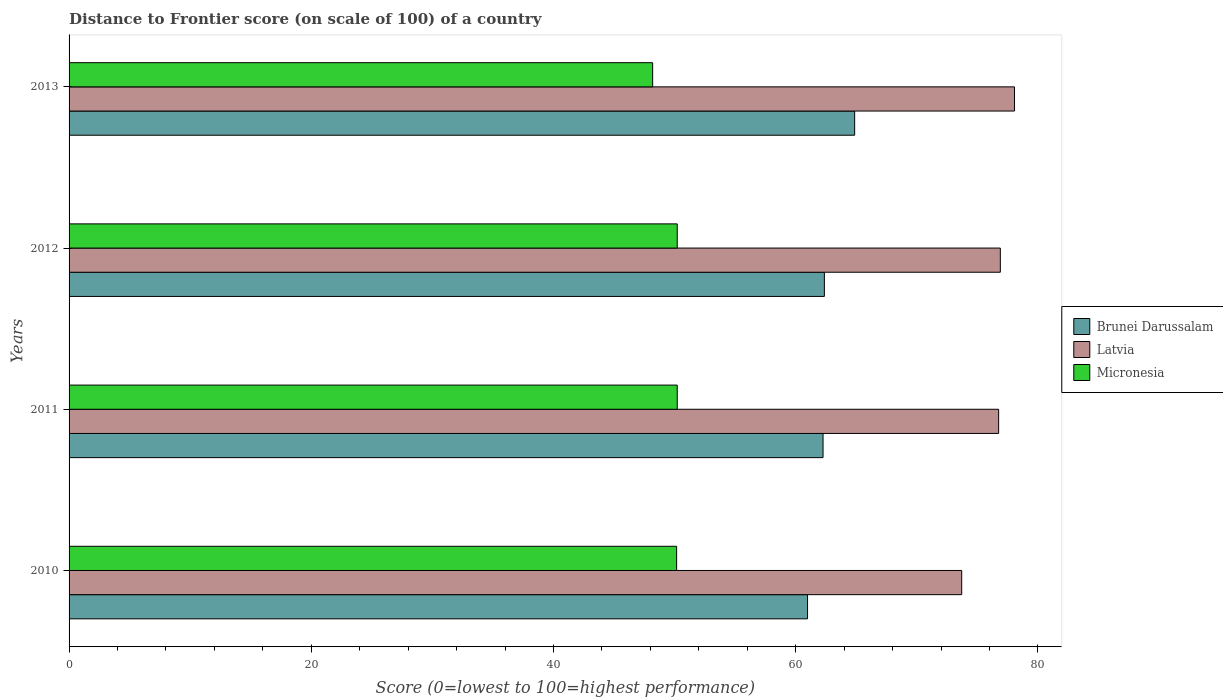How many bars are there on the 4th tick from the bottom?
Your response must be concise. 3. What is the label of the 4th group of bars from the top?
Offer a very short reply. 2010. What is the distance to frontier score of in Brunei Darussalam in 2013?
Provide a short and direct response. 64.87. Across all years, what is the maximum distance to frontier score of in Latvia?
Offer a very short reply. 78.07. Across all years, what is the minimum distance to frontier score of in Latvia?
Make the answer very short. 73.71. What is the total distance to frontier score of in Micronesia in the graph?
Your answer should be very brief. 198.8. What is the difference between the distance to frontier score of in Brunei Darussalam in 2012 and that in 2013?
Make the answer very short. -2.5. What is the difference between the distance to frontier score of in Brunei Darussalam in 2011 and the distance to frontier score of in Latvia in 2013?
Provide a succinct answer. -15.81. What is the average distance to frontier score of in Latvia per year?
Make the answer very short. 76.36. In the year 2010, what is the difference between the distance to frontier score of in Latvia and distance to frontier score of in Micronesia?
Keep it short and to the point. 23.54. What is the ratio of the distance to frontier score of in Brunei Darussalam in 2012 to that in 2013?
Provide a succinct answer. 0.96. What is the difference between the highest and the second highest distance to frontier score of in Micronesia?
Keep it short and to the point. 0. What is the difference between the highest and the lowest distance to frontier score of in Micronesia?
Keep it short and to the point. 2.03. In how many years, is the distance to frontier score of in Brunei Darussalam greater than the average distance to frontier score of in Brunei Darussalam taken over all years?
Your answer should be compact. 1. Is the sum of the distance to frontier score of in Brunei Darussalam in 2010 and 2013 greater than the maximum distance to frontier score of in Latvia across all years?
Give a very brief answer. Yes. What does the 2nd bar from the top in 2012 represents?
Your answer should be very brief. Latvia. What does the 3rd bar from the bottom in 2013 represents?
Ensure brevity in your answer.  Micronesia. How many bars are there?
Provide a succinct answer. 12. Are all the bars in the graph horizontal?
Give a very brief answer. Yes. Are the values on the major ticks of X-axis written in scientific E-notation?
Provide a short and direct response. No. How many legend labels are there?
Give a very brief answer. 3. What is the title of the graph?
Ensure brevity in your answer.  Distance to Frontier score (on scale of 100) of a country. What is the label or title of the X-axis?
Provide a short and direct response. Score (0=lowest to 100=highest performance). What is the Score (0=lowest to 100=highest performance) in Brunei Darussalam in 2010?
Your answer should be compact. 60.98. What is the Score (0=lowest to 100=highest performance) of Latvia in 2010?
Your answer should be very brief. 73.71. What is the Score (0=lowest to 100=highest performance) in Micronesia in 2010?
Provide a short and direct response. 50.17. What is the Score (0=lowest to 100=highest performance) in Brunei Darussalam in 2011?
Your answer should be very brief. 62.26. What is the Score (0=lowest to 100=highest performance) of Latvia in 2011?
Give a very brief answer. 76.76. What is the Score (0=lowest to 100=highest performance) in Micronesia in 2011?
Offer a very short reply. 50.22. What is the Score (0=lowest to 100=highest performance) of Brunei Darussalam in 2012?
Provide a succinct answer. 62.37. What is the Score (0=lowest to 100=highest performance) of Latvia in 2012?
Make the answer very short. 76.9. What is the Score (0=lowest to 100=highest performance) in Micronesia in 2012?
Make the answer very short. 50.22. What is the Score (0=lowest to 100=highest performance) in Brunei Darussalam in 2013?
Provide a short and direct response. 64.87. What is the Score (0=lowest to 100=highest performance) of Latvia in 2013?
Your answer should be compact. 78.07. What is the Score (0=lowest to 100=highest performance) in Micronesia in 2013?
Provide a succinct answer. 48.19. Across all years, what is the maximum Score (0=lowest to 100=highest performance) of Brunei Darussalam?
Make the answer very short. 64.87. Across all years, what is the maximum Score (0=lowest to 100=highest performance) in Latvia?
Keep it short and to the point. 78.07. Across all years, what is the maximum Score (0=lowest to 100=highest performance) in Micronesia?
Give a very brief answer. 50.22. Across all years, what is the minimum Score (0=lowest to 100=highest performance) of Brunei Darussalam?
Your answer should be compact. 60.98. Across all years, what is the minimum Score (0=lowest to 100=highest performance) in Latvia?
Make the answer very short. 73.71. Across all years, what is the minimum Score (0=lowest to 100=highest performance) in Micronesia?
Provide a short and direct response. 48.19. What is the total Score (0=lowest to 100=highest performance) of Brunei Darussalam in the graph?
Provide a succinct answer. 250.48. What is the total Score (0=lowest to 100=highest performance) in Latvia in the graph?
Make the answer very short. 305.44. What is the total Score (0=lowest to 100=highest performance) in Micronesia in the graph?
Offer a very short reply. 198.8. What is the difference between the Score (0=lowest to 100=highest performance) of Brunei Darussalam in 2010 and that in 2011?
Ensure brevity in your answer.  -1.28. What is the difference between the Score (0=lowest to 100=highest performance) in Latvia in 2010 and that in 2011?
Your answer should be compact. -3.05. What is the difference between the Score (0=lowest to 100=highest performance) in Brunei Darussalam in 2010 and that in 2012?
Provide a succinct answer. -1.39. What is the difference between the Score (0=lowest to 100=highest performance) in Latvia in 2010 and that in 2012?
Provide a short and direct response. -3.19. What is the difference between the Score (0=lowest to 100=highest performance) of Brunei Darussalam in 2010 and that in 2013?
Your answer should be compact. -3.89. What is the difference between the Score (0=lowest to 100=highest performance) of Latvia in 2010 and that in 2013?
Your response must be concise. -4.36. What is the difference between the Score (0=lowest to 100=highest performance) in Micronesia in 2010 and that in 2013?
Provide a short and direct response. 1.98. What is the difference between the Score (0=lowest to 100=highest performance) of Brunei Darussalam in 2011 and that in 2012?
Provide a short and direct response. -0.11. What is the difference between the Score (0=lowest to 100=highest performance) of Latvia in 2011 and that in 2012?
Provide a short and direct response. -0.14. What is the difference between the Score (0=lowest to 100=highest performance) of Brunei Darussalam in 2011 and that in 2013?
Keep it short and to the point. -2.61. What is the difference between the Score (0=lowest to 100=highest performance) of Latvia in 2011 and that in 2013?
Your response must be concise. -1.31. What is the difference between the Score (0=lowest to 100=highest performance) of Micronesia in 2011 and that in 2013?
Provide a short and direct response. 2.03. What is the difference between the Score (0=lowest to 100=highest performance) in Latvia in 2012 and that in 2013?
Your response must be concise. -1.17. What is the difference between the Score (0=lowest to 100=highest performance) of Micronesia in 2012 and that in 2013?
Give a very brief answer. 2.03. What is the difference between the Score (0=lowest to 100=highest performance) of Brunei Darussalam in 2010 and the Score (0=lowest to 100=highest performance) of Latvia in 2011?
Your response must be concise. -15.78. What is the difference between the Score (0=lowest to 100=highest performance) of Brunei Darussalam in 2010 and the Score (0=lowest to 100=highest performance) of Micronesia in 2011?
Offer a terse response. 10.76. What is the difference between the Score (0=lowest to 100=highest performance) in Latvia in 2010 and the Score (0=lowest to 100=highest performance) in Micronesia in 2011?
Ensure brevity in your answer.  23.49. What is the difference between the Score (0=lowest to 100=highest performance) of Brunei Darussalam in 2010 and the Score (0=lowest to 100=highest performance) of Latvia in 2012?
Ensure brevity in your answer.  -15.92. What is the difference between the Score (0=lowest to 100=highest performance) of Brunei Darussalam in 2010 and the Score (0=lowest to 100=highest performance) of Micronesia in 2012?
Your response must be concise. 10.76. What is the difference between the Score (0=lowest to 100=highest performance) in Latvia in 2010 and the Score (0=lowest to 100=highest performance) in Micronesia in 2012?
Keep it short and to the point. 23.49. What is the difference between the Score (0=lowest to 100=highest performance) of Brunei Darussalam in 2010 and the Score (0=lowest to 100=highest performance) of Latvia in 2013?
Your answer should be compact. -17.09. What is the difference between the Score (0=lowest to 100=highest performance) in Brunei Darussalam in 2010 and the Score (0=lowest to 100=highest performance) in Micronesia in 2013?
Your answer should be compact. 12.79. What is the difference between the Score (0=lowest to 100=highest performance) of Latvia in 2010 and the Score (0=lowest to 100=highest performance) of Micronesia in 2013?
Your answer should be compact. 25.52. What is the difference between the Score (0=lowest to 100=highest performance) of Brunei Darussalam in 2011 and the Score (0=lowest to 100=highest performance) of Latvia in 2012?
Offer a terse response. -14.64. What is the difference between the Score (0=lowest to 100=highest performance) of Brunei Darussalam in 2011 and the Score (0=lowest to 100=highest performance) of Micronesia in 2012?
Your answer should be compact. 12.04. What is the difference between the Score (0=lowest to 100=highest performance) of Latvia in 2011 and the Score (0=lowest to 100=highest performance) of Micronesia in 2012?
Provide a succinct answer. 26.54. What is the difference between the Score (0=lowest to 100=highest performance) of Brunei Darussalam in 2011 and the Score (0=lowest to 100=highest performance) of Latvia in 2013?
Offer a very short reply. -15.81. What is the difference between the Score (0=lowest to 100=highest performance) of Brunei Darussalam in 2011 and the Score (0=lowest to 100=highest performance) of Micronesia in 2013?
Provide a short and direct response. 14.07. What is the difference between the Score (0=lowest to 100=highest performance) of Latvia in 2011 and the Score (0=lowest to 100=highest performance) of Micronesia in 2013?
Your answer should be compact. 28.57. What is the difference between the Score (0=lowest to 100=highest performance) in Brunei Darussalam in 2012 and the Score (0=lowest to 100=highest performance) in Latvia in 2013?
Give a very brief answer. -15.7. What is the difference between the Score (0=lowest to 100=highest performance) of Brunei Darussalam in 2012 and the Score (0=lowest to 100=highest performance) of Micronesia in 2013?
Ensure brevity in your answer.  14.18. What is the difference between the Score (0=lowest to 100=highest performance) in Latvia in 2012 and the Score (0=lowest to 100=highest performance) in Micronesia in 2013?
Give a very brief answer. 28.71. What is the average Score (0=lowest to 100=highest performance) in Brunei Darussalam per year?
Make the answer very short. 62.62. What is the average Score (0=lowest to 100=highest performance) of Latvia per year?
Keep it short and to the point. 76.36. What is the average Score (0=lowest to 100=highest performance) in Micronesia per year?
Provide a short and direct response. 49.7. In the year 2010, what is the difference between the Score (0=lowest to 100=highest performance) in Brunei Darussalam and Score (0=lowest to 100=highest performance) in Latvia?
Your answer should be compact. -12.73. In the year 2010, what is the difference between the Score (0=lowest to 100=highest performance) of Brunei Darussalam and Score (0=lowest to 100=highest performance) of Micronesia?
Provide a succinct answer. 10.81. In the year 2010, what is the difference between the Score (0=lowest to 100=highest performance) in Latvia and Score (0=lowest to 100=highest performance) in Micronesia?
Give a very brief answer. 23.54. In the year 2011, what is the difference between the Score (0=lowest to 100=highest performance) of Brunei Darussalam and Score (0=lowest to 100=highest performance) of Micronesia?
Your answer should be very brief. 12.04. In the year 2011, what is the difference between the Score (0=lowest to 100=highest performance) in Latvia and Score (0=lowest to 100=highest performance) in Micronesia?
Your answer should be compact. 26.54. In the year 2012, what is the difference between the Score (0=lowest to 100=highest performance) in Brunei Darussalam and Score (0=lowest to 100=highest performance) in Latvia?
Offer a very short reply. -14.53. In the year 2012, what is the difference between the Score (0=lowest to 100=highest performance) in Brunei Darussalam and Score (0=lowest to 100=highest performance) in Micronesia?
Keep it short and to the point. 12.15. In the year 2012, what is the difference between the Score (0=lowest to 100=highest performance) of Latvia and Score (0=lowest to 100=highest performance) of Micronesia?
Keep it short and to the point. 26.68. In the year 2013, what is the difference between the Score (0=lowest to 100=highest performance) of Brunei Darussalam and Score (0=lowest to 100=highest performance) of Latvia?
Ensure brevity in your answer.  -13.2. In the year 2013, what is the difference between the Score (0=lowest to 100=highest performance) in Brunei Darussalam and Score (0=lowest to 100=highest performance) in Micronesia?
Make the answer very short. 16.68. In the year 2013, what is the difference between the Score (0=lowest to 100=highest performance) in Latvia and Score (0=lowest to 100=highest performance) in Micronesia?
Offer a very short reply. 29.88. What is the ratio of the Score (0=lowest to 100=highest performance) of Brunei Darussalam in 2010 to that in 2011?
Ensure brevity in your answer.  0.98. What is the ratio of the Score (0=lowest to 100=highest performance) in Latvia in 2010 to that in 2011?
Provide a short and direct response. 0.96. What is the ratio of the Score (0=lowest to 100=highest performance) in Micronesia in 2010 to that in 2011?
Your answer should be very brief. 1. What is the ratio of the Score (0=lowest to 100=highest performance) of Brunei Darussalam in 2010 to that in 2012?
Provide a short and direct response. 0.98. What is the ratio of the Score (0=lowest to 100=highest performance) of Latvia in 2010 to that in 2012?
Offer a terse response. 0.96. What is the ratio of the Score (0=lowest to 100=highest performance) of Micronesia in 2010 to that in 2012?
Give a very brief answer. 1. What is the ratio of the Score (0=lowest to 100=highest performance) in Latvia in 2010 to that in 2013?
Offer a terse response. 0.94. What is the ratio of the Score (0=lowest to 100=highest performance) of Micronesia in 2010 to that in 2013?
Offer a terse response. 1.04. What is the ratio of the Score (0=lowest to 100=highest performance) of Latvia in 2011 to that in 2012?
Your answer should be compact. 1. What is the ratio of the Score (0=lowest to 100=highest performance) of Micronesia in 2011 to that in 2012?
Your answer should be very brief. 1. What is the ratio of the Score (0=lowest to 100=highest performance) of Brunei Darussalam in 2011 to that in 2013?
Provide a succinct answer. 0.96. What is the ratio of the Score (0=lowest to 100=highest performance) of Latvia in 2011 to that in 2013?
Provide a short and direct response. 0.98. What is the ratio of the Score (0=lowest to 100=highest performance) of Micronesia in 2011 to that in 2013?
Make the answer very short. 1.04. What is the ratio of the Score (0=lowest to 100=highest performance) of Brunei Darussalam in 2012 to that in 2013?
Your answer should be compact. 0.96. What is the ratio of the Score (0=lowest to 100=highest performance) in Micronesia in 2012 to that in 2013?
Offer a very short reply. 1.04. What is the difference between the highest and the second highest Score (0=lowest to 100=highest performance) in Brunei Darussalam?
Offer a terse response. 2.5. What is the difference between the highest and the second highest Score (0=lowest to 100=highest performance) of Latvia?
Your response must be concise. 1.17. What is the difference between the highest and the lowest Score (0=lowest to 100=highest performance) in Brunei Darussalam?
Your response must be concise. 3.89. What is the difference between the highest and the lowest Score (0=lowest to 100=highest performance) of Latvia?
Your answer should be very brief. 4.36. What is the difference between the highest and the lowest Score (0=lowest to 100=highest performance) of Micronesia?
Your answer should be compact. 2.03. 